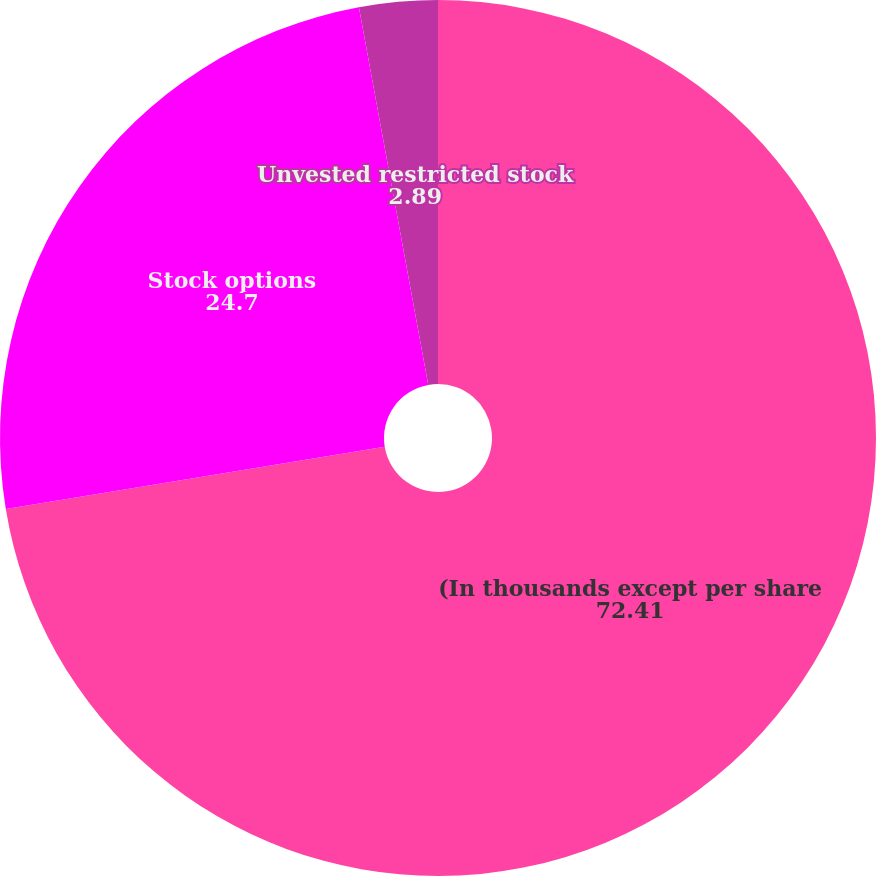Convert chart. <chart><loc_0><loc_0><loc_500><loc_500><pie_chart><fcel>(In thousands except per share<fcel>Stock options<fcel>Unvested restricted stock<nl><fcel>72.41%<fcel>24.7%<fcel>2.89%<nl></chart> 